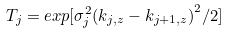<formula> <loc_0><loc_0><loc_500><loc_500>T _ { j } = e x p [ \sigma _ { j } ^ { 2 } { ( k _ { j , z } - k _ { j + 1 , z } ) } ^ { 2 } / 2 ]</formula> 